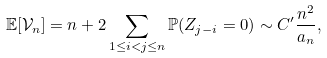<formula> <loc_0><loc_0><loc_500><loc_500>\mathbb { E } [ \mathcal { V } _ { n } ] = n + 2 \sum _ { 1 \leq i < j \leq n } \mathbb { P } ( Z _ { j - i } = 0 ) \sim C ^ { \prime } \frac { n ^ { 2 } } { a _ { n } } ,</formula> 